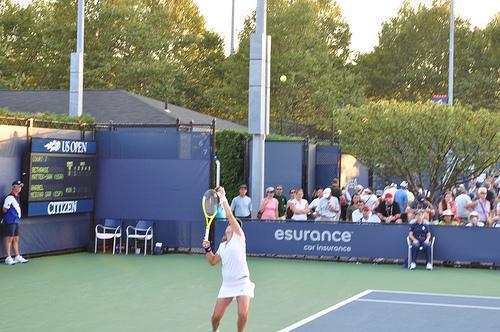How many players are seen?
Give a very brief answer. 1. 